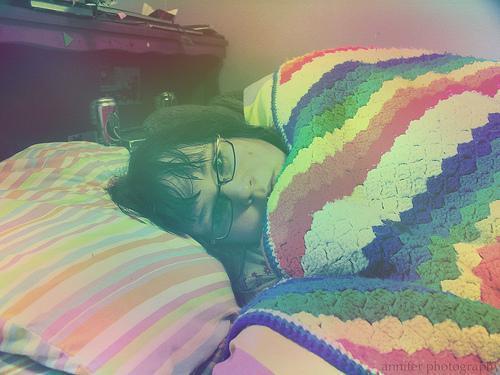How many people are in this picture?
Give a very brief answer. 1. 